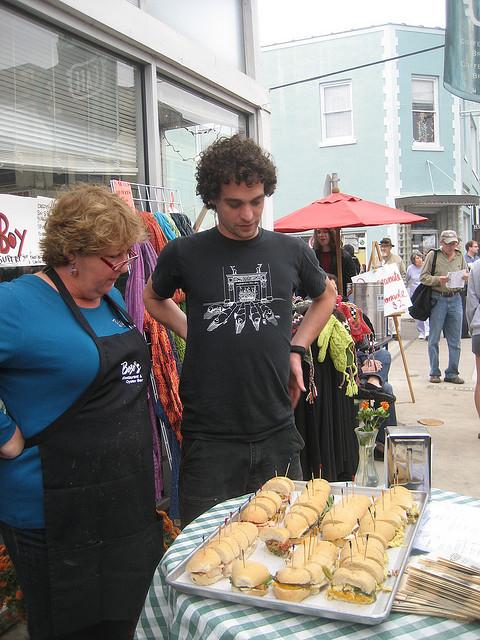Are the lights on?
Short answer required. No. What is on top of the burger?
Answer briefly. Bun. Is anyone shopping?
Write a very short answer. Yes. What color is the umbrella?
Concise answer only. Red. Are the sandwiches all the same?
Quick response, please. No. How many sandwiches does the young man in the photo look like he wants to eat?
Write a very short answer. All of them. What color are their shirts?
Answer briefly. Blue and black. What is the woman looking at in the picture?
Quick response, please. Sandwiches. 